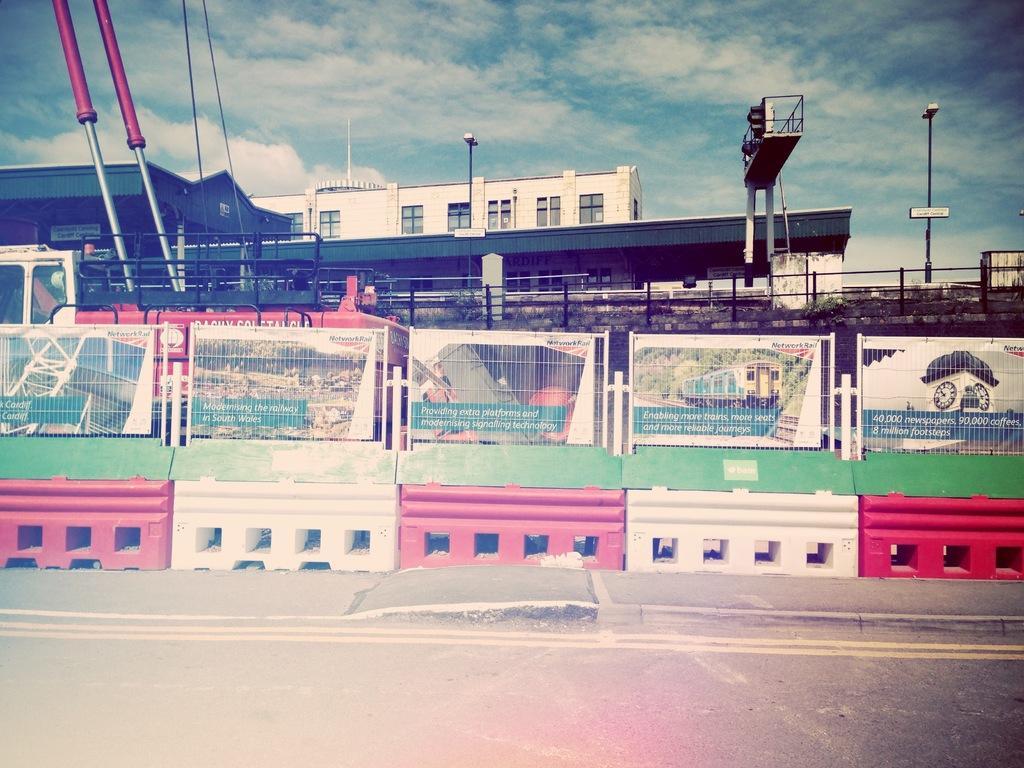Please provide a concise description of this image. In the center of the image there is a fencing and road. In the background there is a traffic signal, a vehicle, building, pole, sky and clouds. 